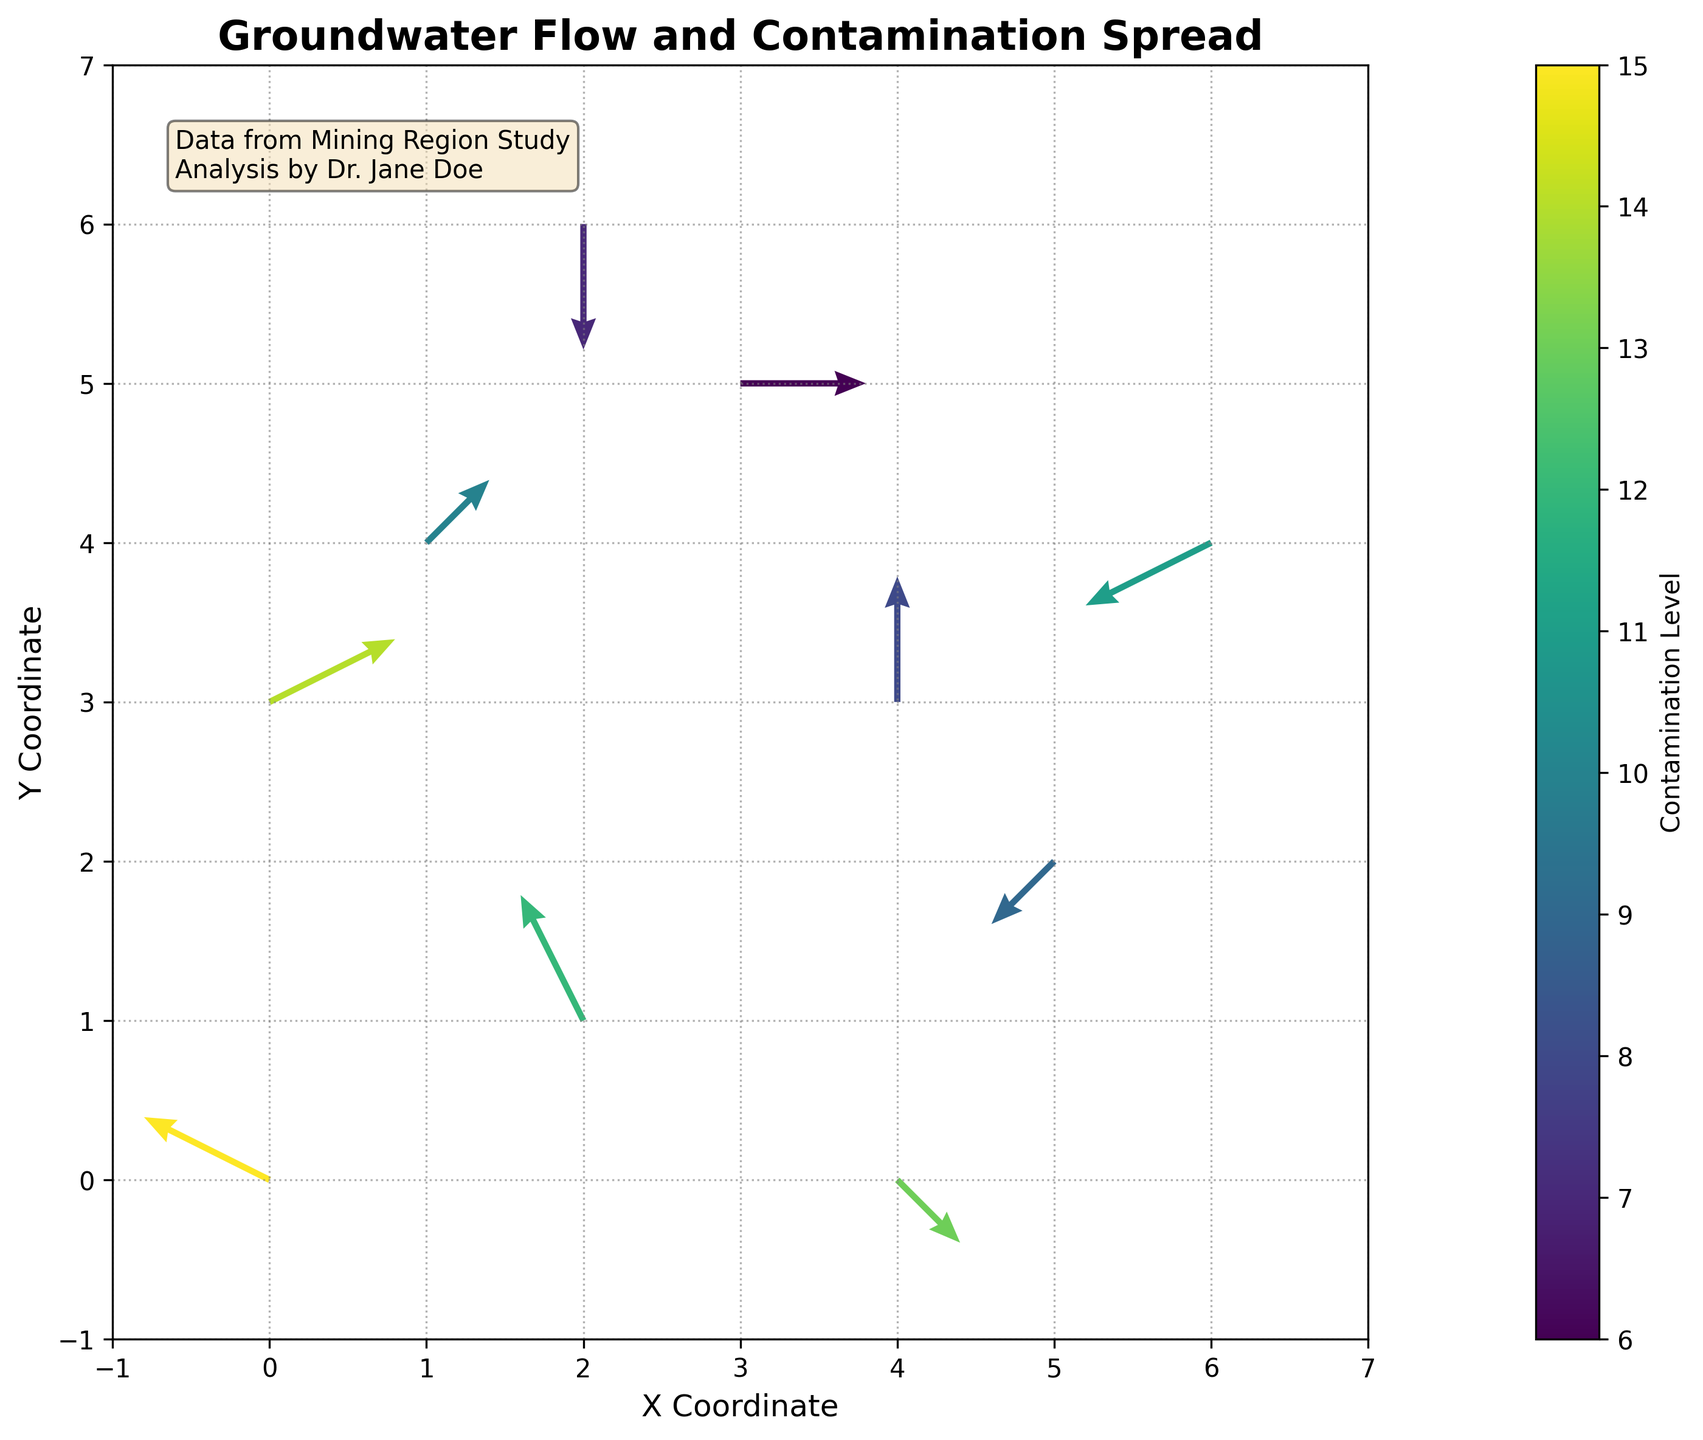What's the title of the figure? The title of the figure is provided at the top of the plot, which is "Groundwater Flow and Contamination Spread".
Answer: Groundwater Flow and Contamination Spread What is the highest contamination level present in the plot? The color bar on the right side of the plot indicates contamination levels, and the highest value is around 15.
Answer: 15 How many data points are represented in the plot? Each quiver arrow represents a data point, and counting the number of arrows in the plot shows there are 10 data points.
Answer: 10 Which data point has the lowest contamination level? The direction and color of the arrows indicate the contamination level. Finding the arrow corresponding to the lightest color indicates the lowest contamination level, which is at coordinates (3, 5) with a value of 6.
Answer: (3, 5) What does the color of the arrows represent? The color of the arrows corresponds to contamination levels, as indicated by the color bar labeled "Contamination Level".
Answer: Contamination levels Compare the contamination levels at coordinates (0, 0) and (0, 3). Which one is higher? Checking the arrows' coordinates and their color: (0, 0) is darker compared to (0, 3), hence it has a higher contamination level. The contamination levels are 15 and 14 respectively.
Answer: (0, 0) In which direction does the groundwater flow at the point (2, 1)? The quiver plot arrow at (2, 1) points in the direction of the groundwater flow. The arrow direction is primarily downward and slightly to the left, indicating the flow is towards the southwest.
Answer: Southwest What's the average contamination level of all data points? The sum of all contamination levels is 15+12+8+10+6+9+7+11+13+14 = 105. Dividing by 10 data points, the average contamination level is 10.5.
Answer: 10.5 How does the direction of the groundwater flow generally trend across the plot? By observing the arrows across the entire plot, most arrows point towards the bottom-left, indicating a general southwestward flow.
Answer: Southwest At which coordinate do we see an upward groundwater flow with zero change in the x-direction? The arrows provide the direction of flow. The arrow at (4, 3) points straight up with no left or right component (u=0, v=2).
Answer: (4, 3) Compare the flow direction at coordinates (4, 0) and (5, 2). How do they differ? At (4, 0), the arrow points downward, indicating southward flow, while at (5, 2), the arrow points diagonally to the southwest, indicating a combination of westward and southward flow.
Answer: Southward vs Southwest 